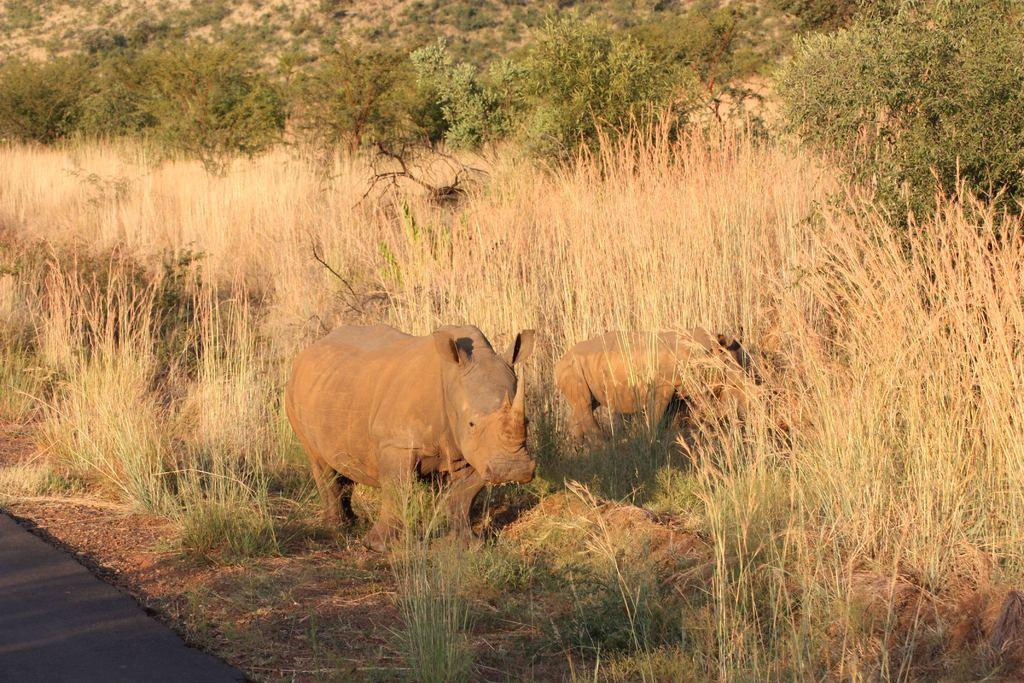What is the main subject in the center of the image? There is a hippopotamus in the center of the image. What can be seen in the background of the image? There are trees and plants in the background of the image. What is visible at the bottom of the image? There is a road visible at the bottom of the image. Can you see the hippopotamus touching the pie in the image? There is no pie present in the image, and the hippopotamus is not touching anything. 